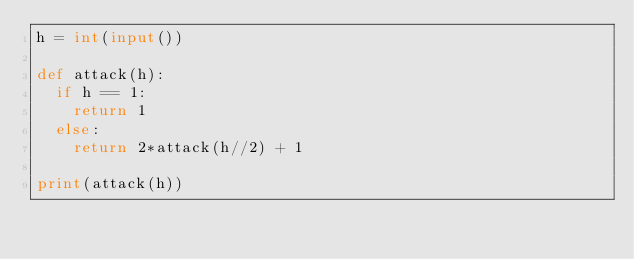Convert code to text. <code><loc_0><loc_0><loc_500><loc_500><_Python_>h = int(input())

def attack(h):
	if h == 1:
		return 1
	else:
		return 2*attack(h//2) + 1

print(attack(h))</code> 